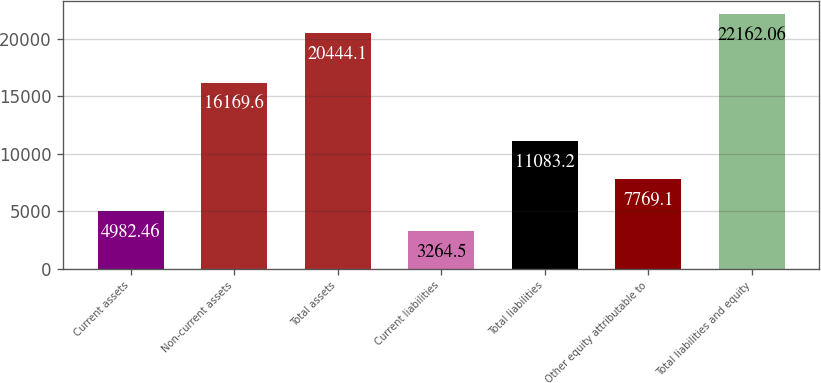Convert chart. <chart><loc_0><loc_0><loc_500><loc_500><bar_chart><fcel>Current assets<fcel>Non-current assets<fcel>Total assets<fcel>Current liabilities<fcel>Total liabilities<fcel>Other equity attributable to<fcel>Total liabilities and equity<nl><fcel>4982.46<fcel>16169.6<fcel>20444.1<fcel>3264.5<fcel>11083.2<fcel>7769.1<fcel>22162.1<nl></chart> 